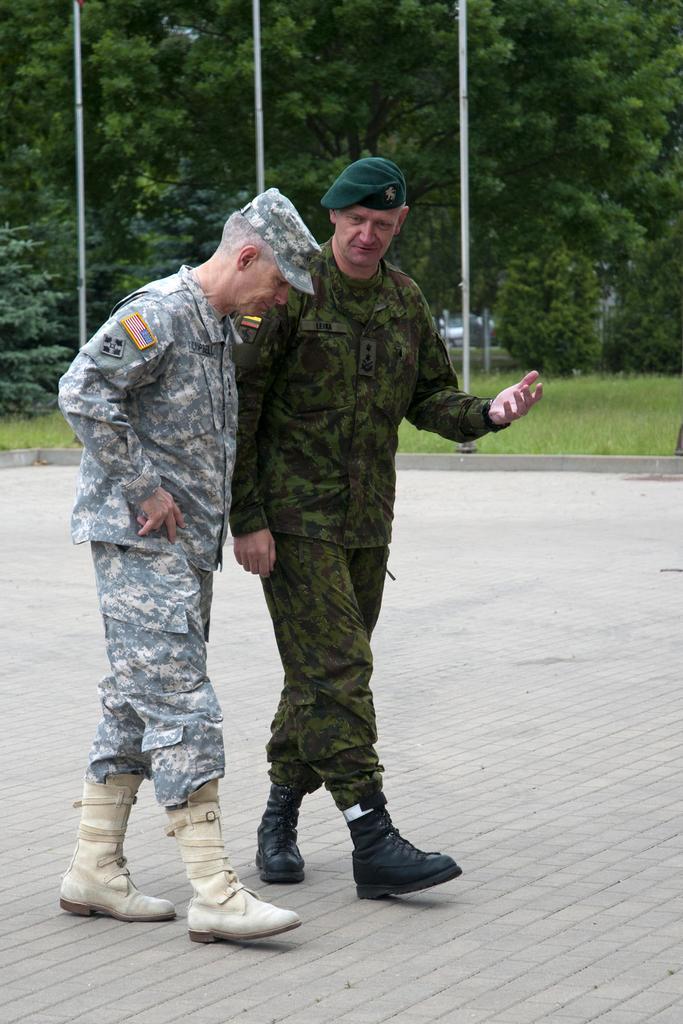Describe this image in one or two sentences. In this image we can see two persons walking on the floor, there are poles, grass, trees, and plants. 